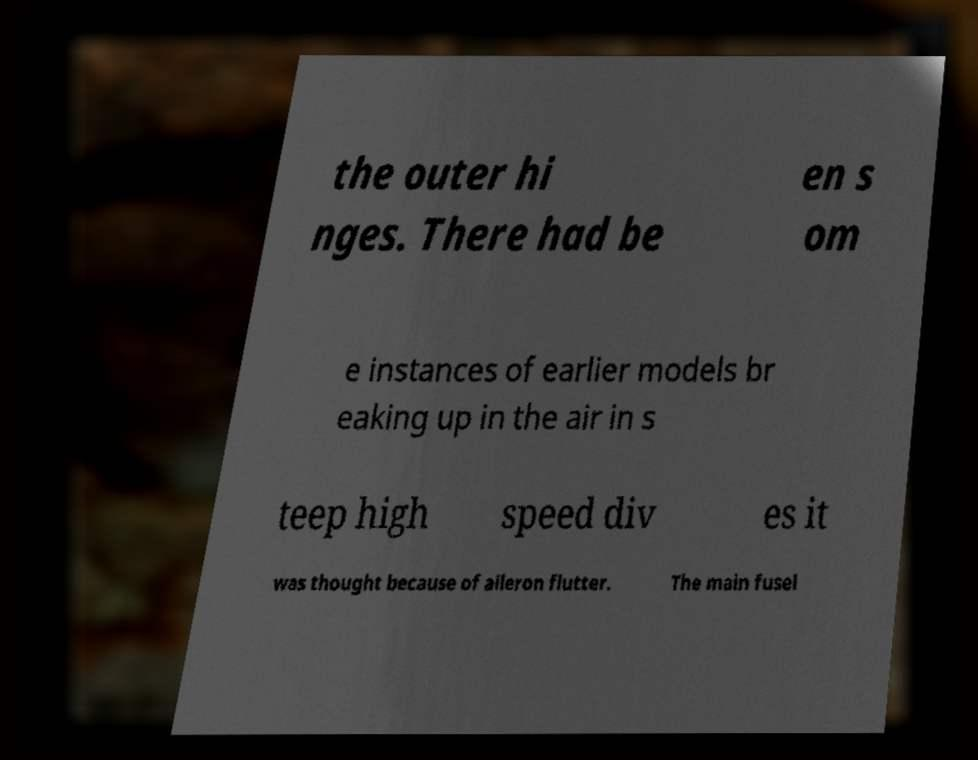Can you accurately transcribe the text from the provided image for me? the outer hi nges. There had be en s om e instances of earlier models br eaking up in the air in s teep high speed div es it was thought because of aileron flutter. The main fusel 